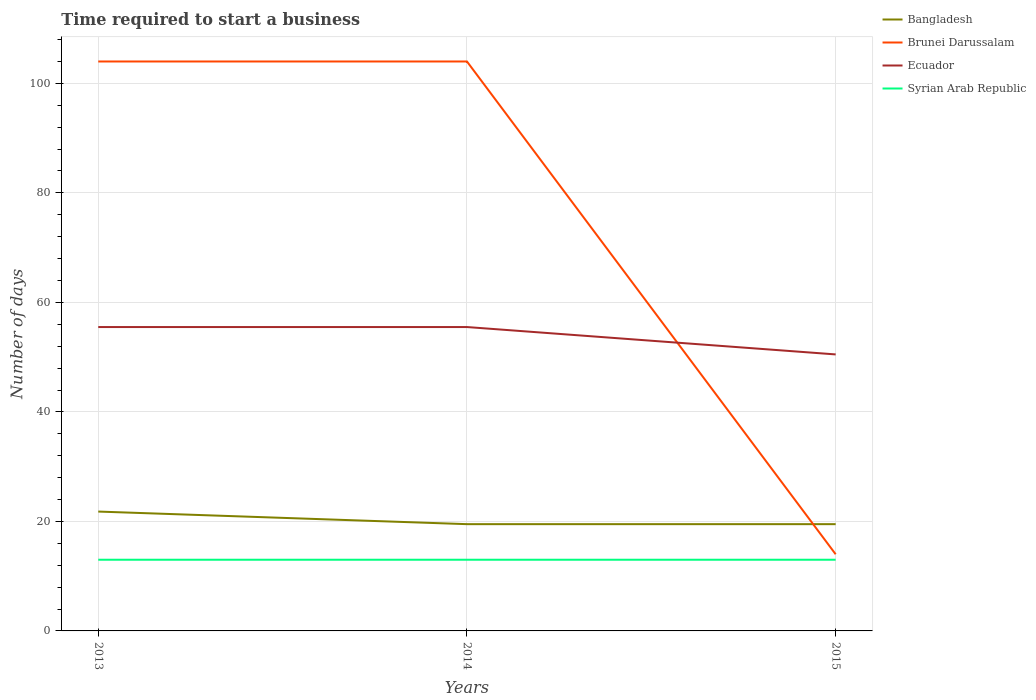How many different coloured lines are there?
Provide a short and direct response. 4. Is the number of lines equal to the number of legend labels?
Your answer should be very brief. Yes. What is the total number of days required to start a business in Bangladesh in the graph?
Offer a terse response. 2.3. Is the number of days required to start a business in Ecuador strictly greater than the number of days required to start a business in Syrian Arab Republic over the years?
Provide a short and direct response. No. Does the graph contain grids?
Keep it short and to the point. Yes. Where does the legend appear in the graph?
Keep it short and to the point. Top right. How many legend labels are there?
Give a very brief answer. 4. What is the title of the graph?
Give a very brief answer. Time required to start a business. What is the label or title of the Y-axis?
Give a very brief answer. Number of days. What is the Number of days of Bangladesh in 2013?
Keep it short and to the point. 21.8. What is the Number of days of Brunei Darussalam in 2013?
Ensure brevity in your answer.  104. What is the Number of days in Ecuador in 2013?
Provide a short and direct response. 55.5. What is the Number of days in Bangladesh in 2014?
Your answer should be very brief. 19.5. What is the Number of days of Brunei Darussalam in 2014?
Provide a succinct answer. 104. What is the Number of days in Ecuador in 2014?
Ensure brevity in your answer.  55.5. What is the Number of days in Bangladesh in 2015?
Ensure brevity in your answer.  19.5. What is the Number of days of Ecuador in 2015?
Provide a short and direct response. 50.5. Across all years, what is the maximum Number of days of Bangladesh?
Your answer should be very brief. 21.8. Across all years, what is the maximum Number of days of Brunei Darussalam?
Give a very brief answer. 104. Across all years, what is the maximum Number of days of Ecuador?
Your answer should be compact. 55.5. Across all years, what is the minimum Number of days in Bangladesh?
Ensure brevity in your answer.  19.5. Across all years, what is the minimum Number of days in Brunei Darussalam?
Keep it short and to the point. 14. Across all years, what is the minimum Number of days of Ecuador?
Provide a short and direct response. 50.5. Across all years, what is the minimum Number of days in Syrian Arab Republic?
Keep it short and to the point. 13. What is the total Number of days in Bangladesh in the graph?
Your response must be concise. 60.8. What is the total Number of days of Brunei Darussalam in the graph?
Offer a terse response. 222. What is the total Number of days in Ecuador in the graph?
Your answer should be very brief. 161.5. What is the difference between the Number of days of Ecuador in 2013 and that in 2014?
Your answer should be very brief. 0. What is the difference between the Number of days in Bangladesh in 2013 and that in 2015?
Provide a succinct answer. 2.3. What is the difference between the Number of days in Brunei Darussalam in 2013 and that in 2015?
Your answer should be very brief. 90. What is the difference between the Number of days of Ecuador in 2013 and that in 2015?
Make the answer very short. 5. What is the difference between the Number of days in Syrian Arab Republic in 2013 and that in 2015?
Provide a succinct answer. 0. What is the difference between the Number of days in Brunei Darussalam in 2014 and that in 2015?
Your answer should be compact. 90. What is the difference between the Number of days in Bangladesh in 2013 and the Number of days in Brunei Darussalam in 2014?
Your answer should be very brief. -82.2. What is the difference between the Number of days in Bangladesh in 2013 and the Number of days in Ecuador in 2014?
Make the answer very short. -33.7. What is the difference between the Number of days of Bangladesh in 2013 and the Number of days of Syrian Arab Republic in 2014?
Provide a succinct answer. 8.8. What is the difference between the Number of days of Brunei Darussalam in 2013 and the Number of days of Ecuador in 2014?
Ensure brevity in your answer.  48.5. What is the difference between the Number of days in Brunei Darussalam in 2013 and the Number of days in Syrian Arab Republic in 2014?
Give a very brief answer. 91. What is the difference between the Number of days in Ecuador in 2013 and the Number of days in Syrian Arab Republic in 2014?
Your answer should be compact. 42.5. What is the difference between the Number of days of Bangladesh in 2013 and the Number of days of Ecuador in 2015?
Provide a succinct answer. -28.7. What is the difference between the Number of days in Brunei Darussalam in 2013 and the Number of days in Ecuador in 2015?
Keep it short and to the point. 53.5. What is the difference between the Number of days in Brunei Darussalam in 2013 and the Number of days in Syrian Arab Republic in 2015?
Your answer should be very brief. 91. What is the difference between the Number of days of Ecuador in 2013 and the Number of days of Syrian Arab Republic in 2015?
Ensure brevity in your answer.  42.5. What is the difference between the Number of days in Bangladesh in 2014 and the Number of days in Ecuador in 2015?
Ensure brevity in your answer.  -31. What is the difference between the Number of days of Bangladesh in 2014 and the Number of days of Syrian Arab Republic in 2015?
Give a very brief answer. 6.5. What is the difference between the Number of days of Brunei Darussalam in 2014 and the Number of days of Ecuador in 2015?
Your response must be concise. 53.5. What is the difference between the Number of days of Brunei Darussalam in 2014 and the Number of days of Syrian Arab Republic in 2015?
Provide a short and direct response. 91. What is the difference between the Number of days in Ecuador in 2014 and the Number of days in Syrian Arab Republic in 2015?
Provide a short and direct response. 42.5. What is the average Number of days of Bangladesh per year?
Your response must be concise. 20.27. What is the average Number of days of Ecuador per year?
Your answer should be very brief. 53.83. What is the average Number of days of Syrian Arab Republic per year?
Provide a succinct answer. 13. In the year 2013, what is the difference between the Number of days in Bangladesh and Number of days in Brunei Darussalam?
Your response must be concise. -82.2. In the year 2013, what is the difference between the Number of days in Bangladesh and Number of days in Ecuador?
Provide a short and direct response. -33.7. In the year 2013, what is the difference between the Number of days of Brunei Darussalam and Number of days of Ecuador?
Offer a terse response. 48.5. In the year 2013, what is the difference between the Number of days in Brunei Darussalam and Number of days in Syrian Arab Republic?
Offer a very short reply. 91. In the year 2013, what is the difference between the Number of days in Ecuador and Number of days in Syrian Arab Republic?
Ensure brevity in your answer.  42.5. In the year 2014, what is the difference between the Number of days in Bangladesh and Number of days in Brunei Darussalam?
Ensure brevity in your answer.  -84.5. In the year 2014, what is the difference between the Number of days in Bangladesh and Number of days in Ecuador?
Keep it short and to the point. -36. In the year 2014, what is the difference between the Number of days of Bangladesh and Number of days of Syrian Arab Republic?
Your response must be concise. 6.5. In the year 2014, what is the difference between the Number of days of Brunei Darussalam and Number of days of Ecuador?
Offer a very short reply. 48.5. In the year 2014, what is the difference between the Number of days in Brunei Darussalam and Number of days in Syrian Arab Republic?
Keep it short and to the point. 91. In the year 2014, what is the difference between the Number of days of Ecuador and Number of days of Syrian Arab Republic?
Your answer should be compact. 42.5. In the year 2015, what is the difference between the Number of days in Bangladesh and Number of days in Brunei Darussalam?
Your answer should be compact. 5.5. In the year 2015, what is the difference between the Number of days in Bangladesh and Number of days in Ecuador?
Provide a short and direct response. -31. In the year 2015, what is the difference between the Number of days of Bangladesh and Number of days of Syrian Arab Republic?
Provide a short and direct response. 6.5. In the year 2015, what is the difference between the Number of days in Brunei Darussalam and Number of days in Ecuador?
Offer a very short reply. -36.5. In the year 2015, what is the difference between the Number of days of Brunei Darussalam and Number of days of Syrian Arab Republic?
Provide a succinct answer. 1. In the year 2015, what is the difference between the Number of days in Ecuador and Number of days in Syrian Arab Republic?
Your answer should be compact. 37.5. What is the ratio of the Number of days in Bangladesh in 2013 to that in 2014?
Keep it short and to the point. 1.12. What is the ratio of the Number of days in Brunei Darussalam in 2013 to that in 2014?
Your response must be concise. 1. What is the ratio of the Number of days of Ecuador in 2013 to that in 2014?
Your answer should be very brief. 1. What is the ratio of the Number of days of Syrian Arab Republic in 2013 to that in 2014?
Give a very brief answer. 1. What is the ratio of the Number of days of Bangladesh in 2013 to that in 2015?
Keep it short and to the point. 1.12. What is the ratio of the Number of days in Brunei Darussalam in 2013 to that in 2015?
Offer a terse response. 7.43. What is the ratio of the Number of days of Ecuador in 2013 to that in 2015?
Your answer should be compact. 1.1. What is the ratio of the Number of days in Syrian Arab Republic in 2013 to that in 2015?
Ensure brevity in your answer.  1. What is the ratio of the Number of days of Brunei Darussalam in 2014 to that in 2015?
Provide a short and direct response. 7.43. What is the ratio of the Number of days of Ecuador in 2014 to that in 2015?
Offer a terse response. 1.1. What is the difference between the highest and the second highest Number of days in Brunei Darussalam?
Keep it short and to the point. 0. What is the difference between the highest and the second highest Number of days of Syrian Arab Republic?
Your answer should be compact. 0. What is the difference between the highest and the lowest Number of days in Brunei Darussalam?
Keep it short and to the point. 90. 